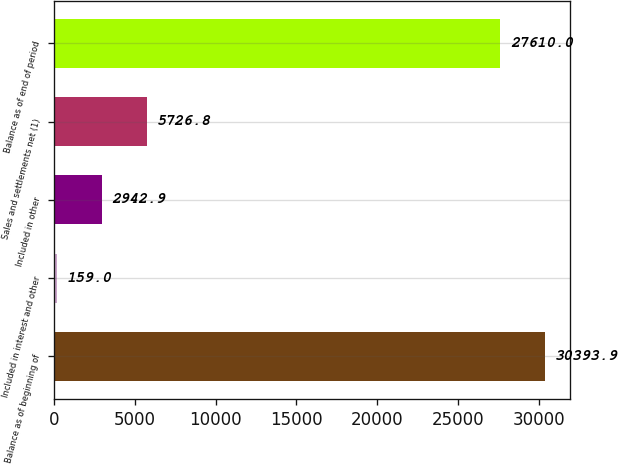Convert chart. <chart><loc_0><loc_0><loc_500><loc_500><bar_chart><fcel>Balance as of beginning of<fcel>Included in interest and other<fcel>Included in other<fcel>Sales and settlements net (1)<fcel>Balance as of end of period<nl><fcel>30393.9<fcel>159<fcel>2942.9<fcel>5726.8<fcel>27610<nl></chart> 